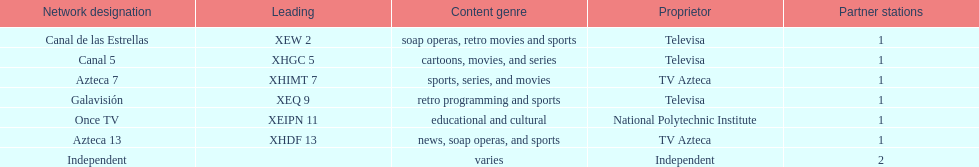How many networks do not air sports? 2. 